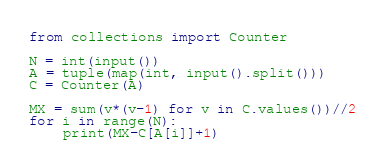Convert code to text. <code><loc_0><loc_0><loc_500><loc_500><_Python_>from collections import Counter

N = int(input())
A = tuple(map(int, input().split()))
C = Counter(A)

MX = sum(v*(v-1) for v in C.values())//2
for i in range(N):
    print(MX-C[A[i]]+1)
</code> 